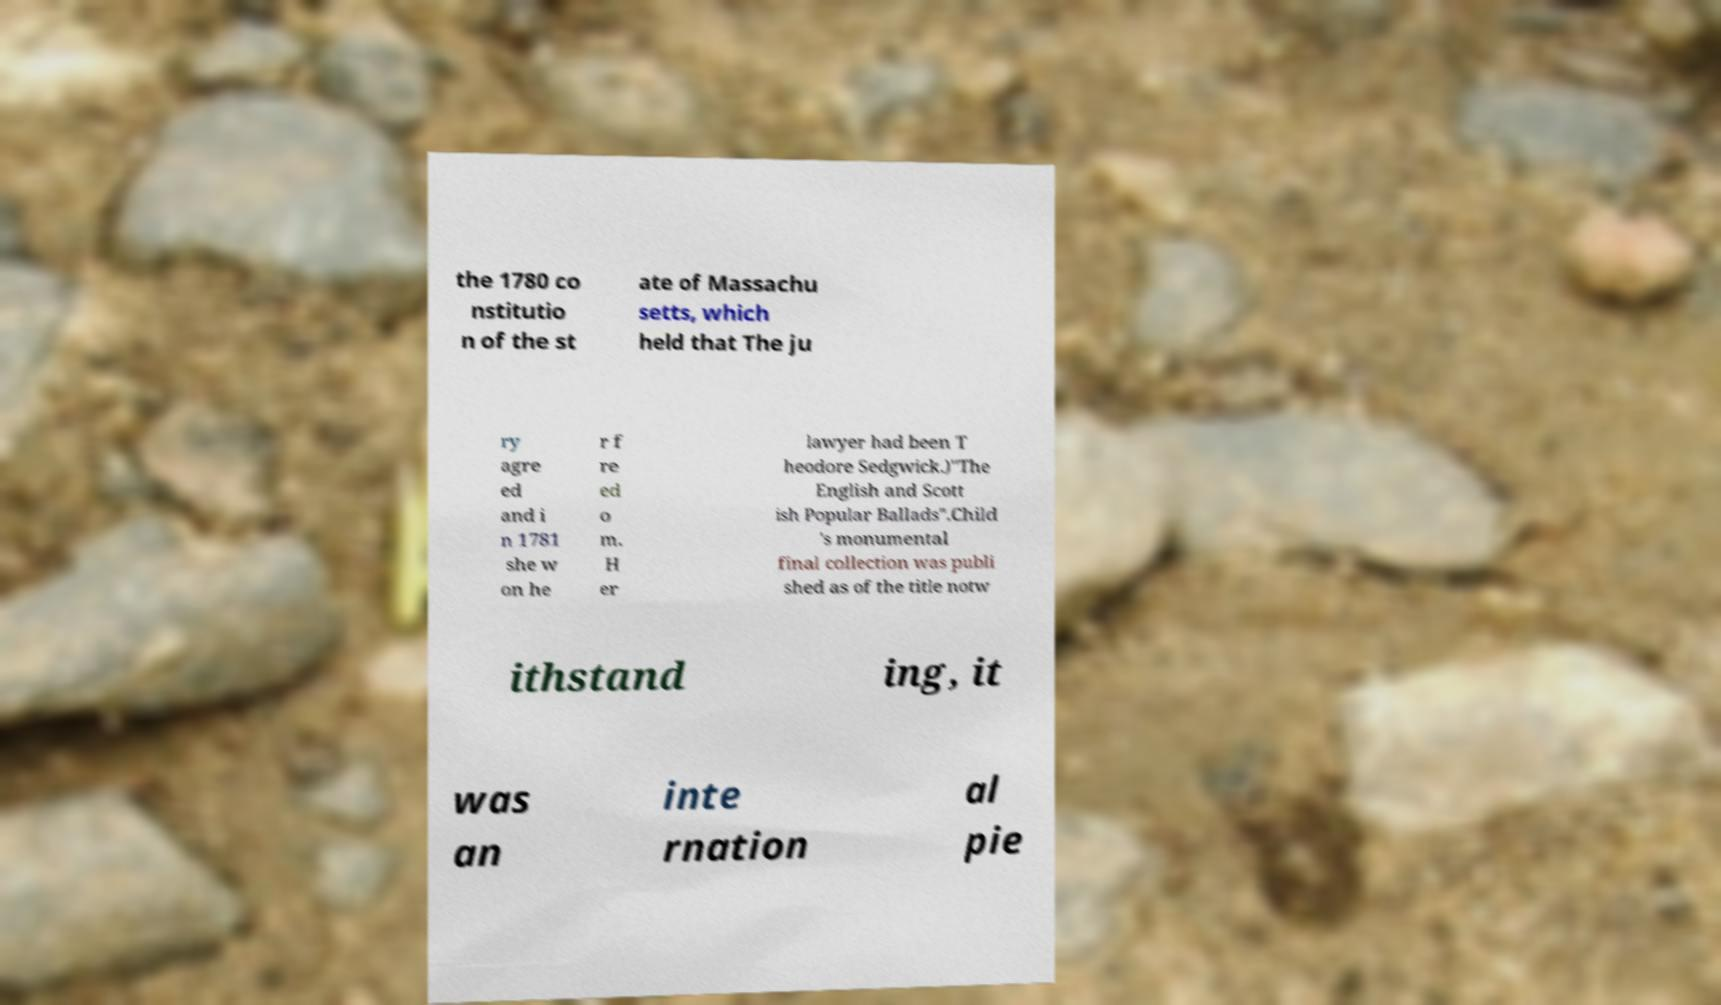Can you read and provide the text displayed in the image?This photo seems to have some interesting text. Can you extract and type it out for me? the 1780 co nstitutio n of the st ate of Massachu setts, which held that The ju ry agre ed and i n 1781 she w on he r f re ed o m. H er lawyer had been T heodore Sedgwick.)"The English and Scott ish Popular Ballads".Child 's monumental final collection was publi shed as of the title notw ithstand ing, it was an inte rnation al pie 